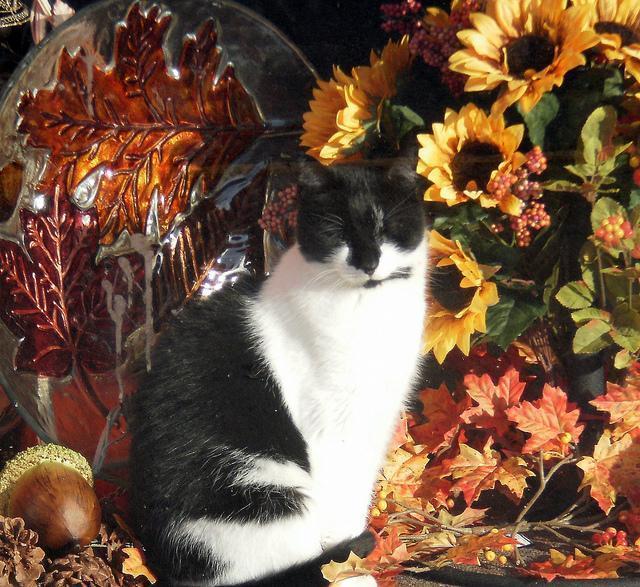How many slices of pizza did the person cut?
Give a very brief answer. 0. 